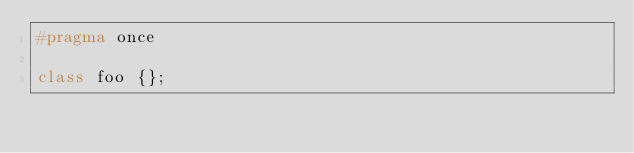<code> <loc_0><loc_0><loc_500><loc_500><_C++_>#pragma once

class foo {};
</code> 